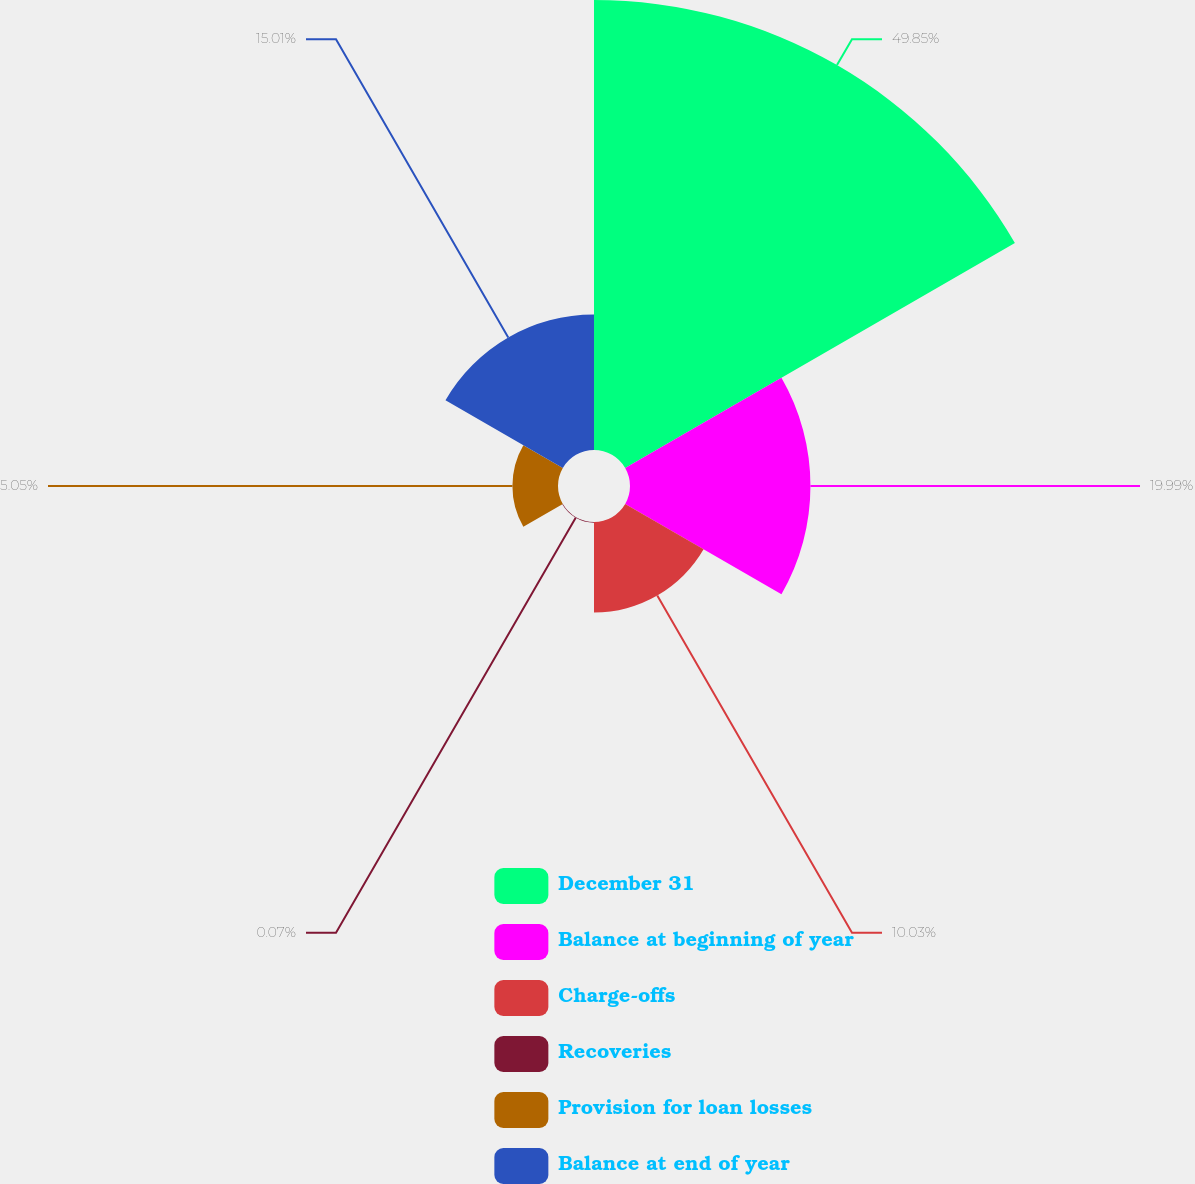Convert chart. <chart><loc_0><loc_0><loc_500><loc_500><pie_chart><fcel>December 31<fcel>Balance at beginning of year<fcel>Charge-offs<fcel>Recoveries<fcel>Provision for loan losses<fcel>Balance at end of year<nl><fcel>49.85%<fcel>19.99%<fcel>10.03%<fcel>0.07%<fcel>5.05%<fcel>15.01%<nl></chart> 